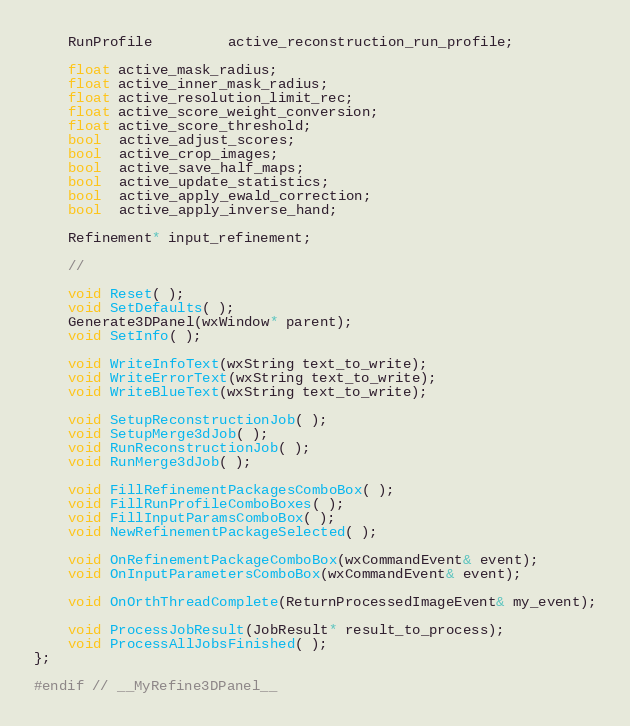Convert code to text. <code><loc_0><loc_0><loc_500><loc_500><_C_>    RunProfile         active_reconstruction_run_profile;

    float active_mask_radius;
    float active_inner_mask_radius;
    float active_resolution_limit_rec;
    float active_score_weight_conversion;
    float active_score_threshold;
    bool  active_adjust_scores;
    bool  active_crop_images;
    bool  active_save_half_maps;
    bool  active_update_statistics;
    bool  active_apply_ewald_correction;
    bool  active_apply_inverse_hand;

    Refinement* input_refinement;

    //

    void Reset( );
    void SetDefaults( );
    Generate3DPanel(wxWindow* parent);
    void SetInfo( );

    void WriteInfoText(wxString text_to_write);
    void WriteErrorText(wxString text_to_write);
    void WriteBlueText(wxString text_to_write);

    void SetupReconstructionJob( );
    void SetupMerge3dJob( );
    void RunReconstructionJob( );
    void RunMerge3dJob( );

    void FillRefinementPackagesComboBox( );
    void FillRunProfileComboBoxes( );
    void FillInputParamsComboBox( );
    void NewRefinementPackageSelected( );

    void OnRefinementPackageComboBox(wxCommandEvent& event);
    void OnInputParametersComboBox(wxCommandEvent& event);

    void OnOrthThreadComplete(ReturnProcessedImageEvent& my_event);

    void ProcessJobResult(JobResult* result_to_process);
    void ProcessAllJobsFinished( );
};

#endif // __MyRefine3DPanel__
</code> 